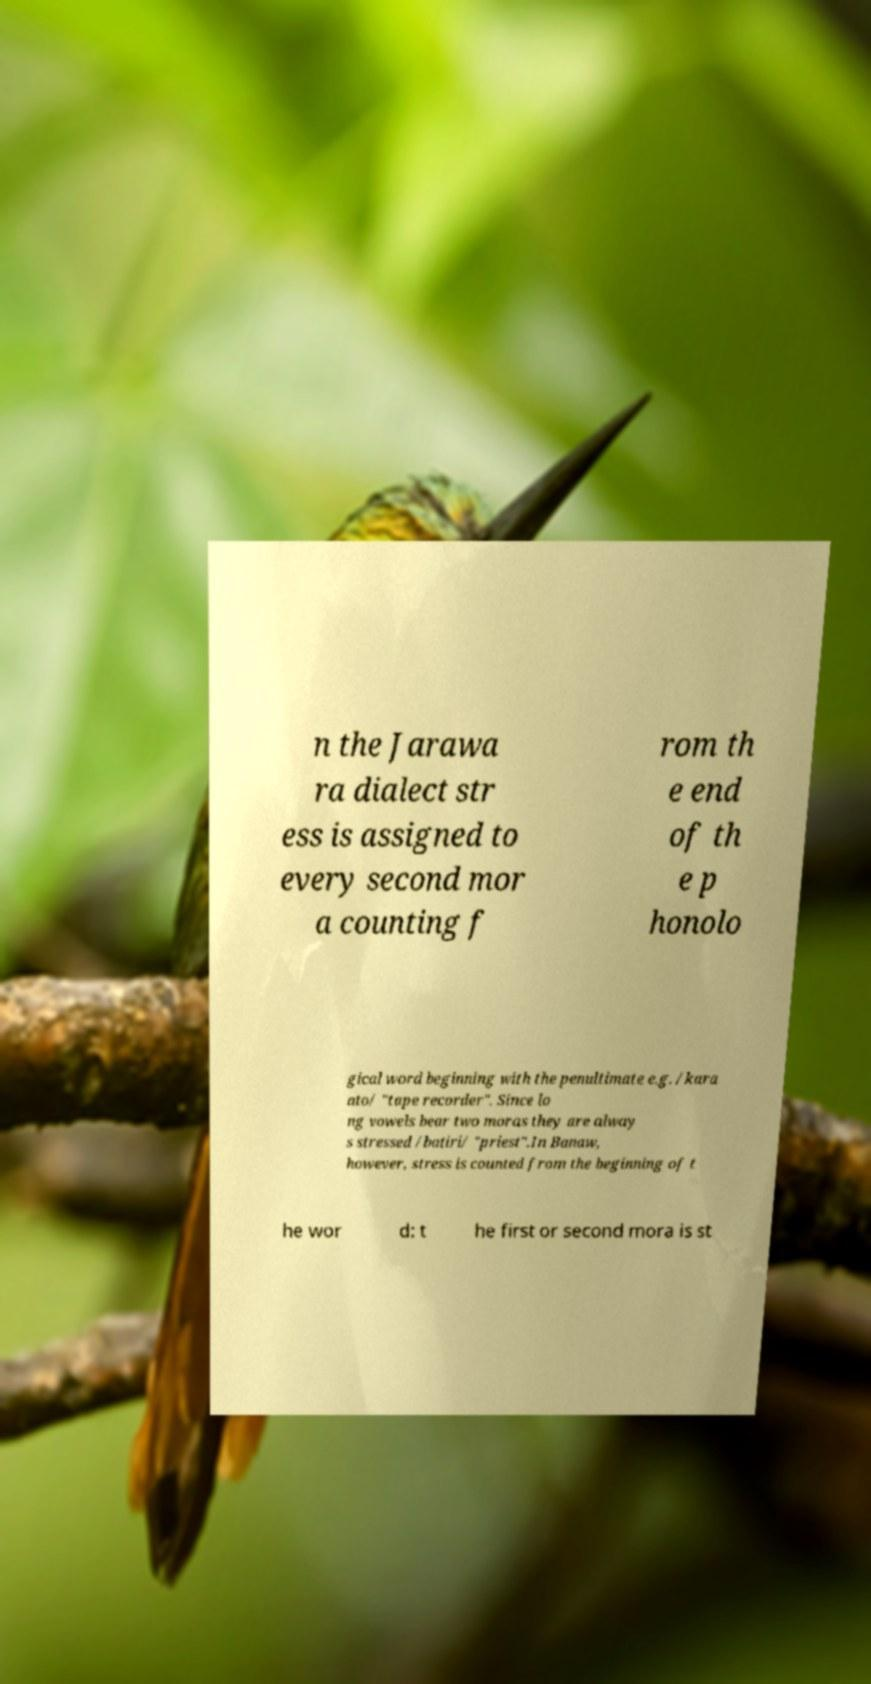There's text embedded in this image that I need extracted. Can you transcribe it verbatim? n the Jarawa ra dialect str ess is assigned to every second mor a counting f rom th e end of th e p honolo gical word beginning with the penultimate e.g. /kara ato/ "tape recorder". Since lo ng vowels bear two moras they are alway s stressed /batiri/ "priest".In Banaw, however, stress is counted from the beginning of t he wor d: t he first or second mora is st 